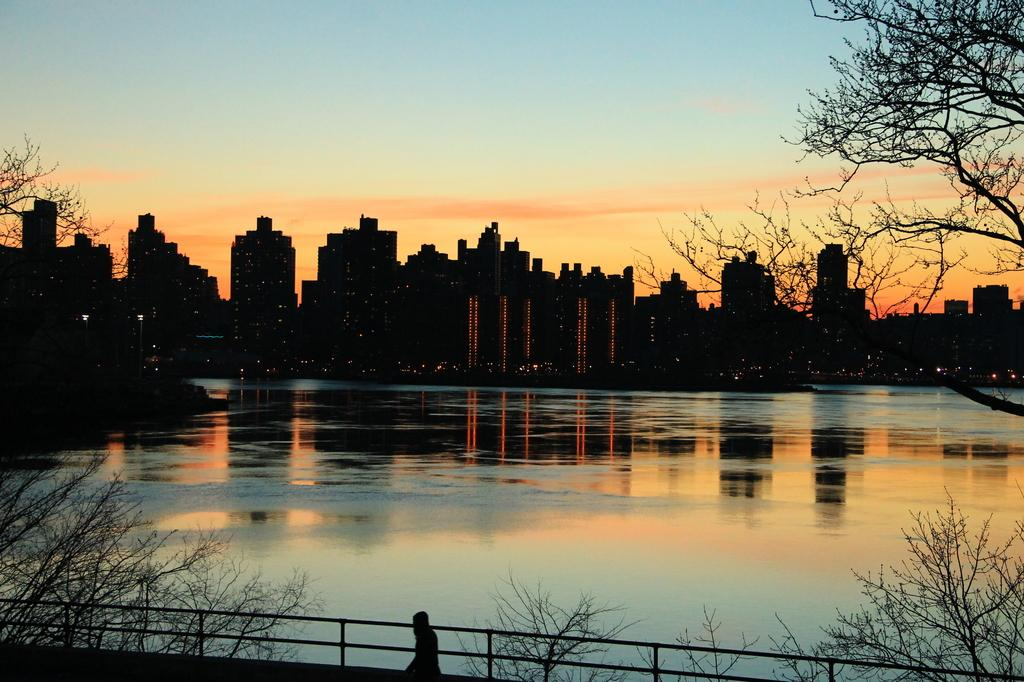What type of structure can be seen in the image? There is fencing in the image. Can you describe the person at the bottom of the image? There is a person at the bottom of the image. What type of natural elements are visible in the image? Trees and water are visible in the image. What type of man-made structures are present in the image? Buildings are present in the image. What type of illumination is visible in the image? Lights are visible in the image. Are there any other objects present in the image besides the ones mentioned? Yes, other objects are present in the image. What can be seen in the sky in the image? The sky is visible in the image. What type of side trade is the person engaging in with the spy in the image? There is no mention of trade or spies in the image; it features fencing, a person, trees, water, buildings, lights, and other objects. 